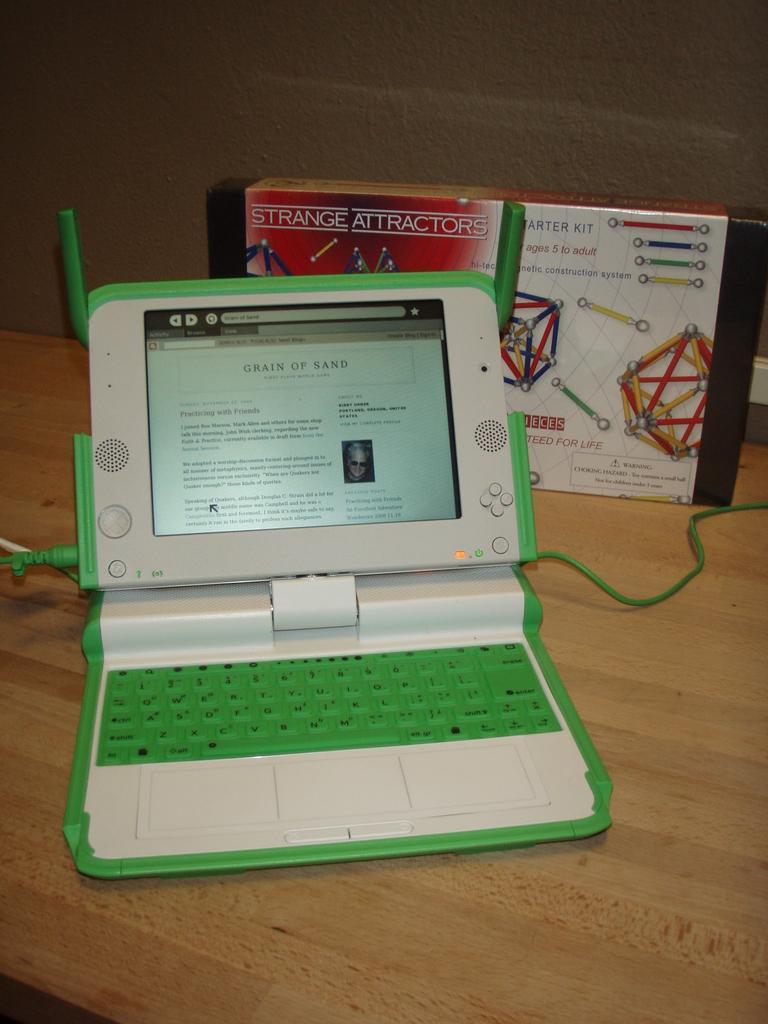Could you give a brief overview of what you see in this image? In this image there is a laptop, behind the laptop there is a box and a cable are on the top of a desk. 